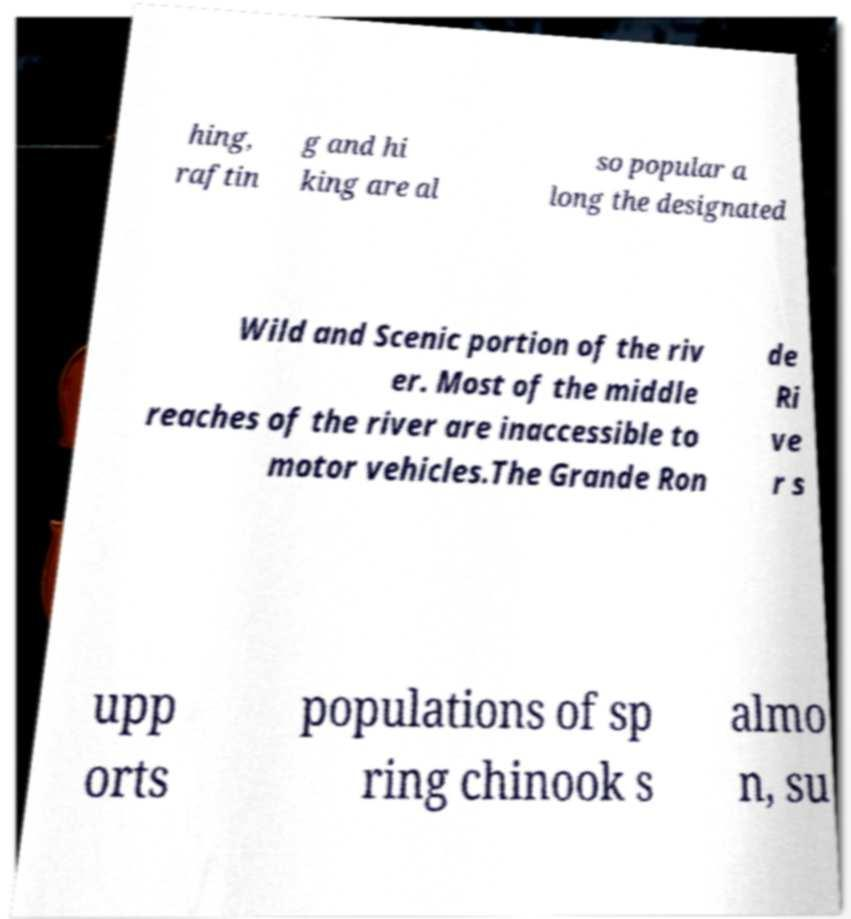Could you assist in decoding the text presented in this image and type it out clearly? hing, raftin g and hi king are al so popular a long the designated Wild and Scenic portion of the riv er. Most of the middle reaches of the river are inaccessible to motor vehicles.The Grande Ron de Ri ve r s upp orts populations of sp ring chinook s almo n, su 